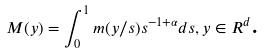Convert formula to latex. <formula><loc_0><loc_0><loc_500><loc_500>M ( y ) = \int _ { 0 } ^ { 1 } m ( y / s ) s ^ { - 1 + \alpha } d s , y \in R ^ { d } \text {.}</formula> 